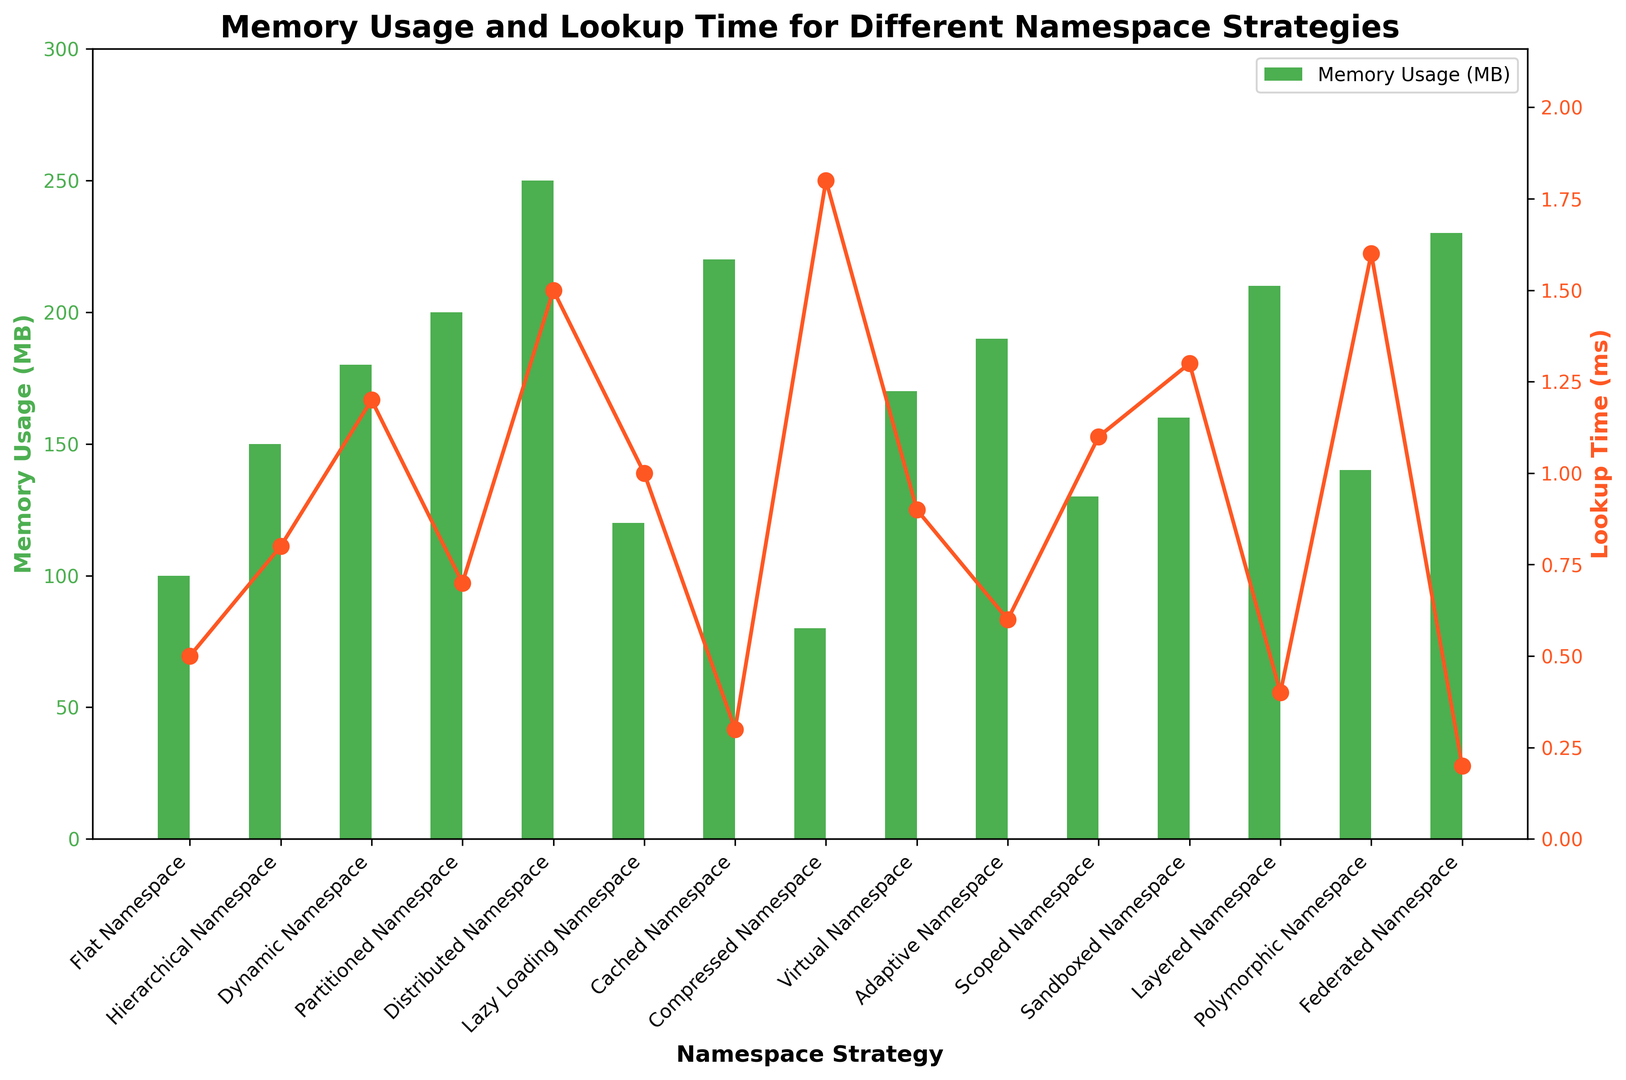Which namespace strategy has the highest memory usage? The green bar that represents memory usage is the tallest for the Distributed Namespace strategy.
Answer: Distributed Namespace Which namespace strategy has the lowest lookup time? The orange line representing lookup time has the lowest point for the Federated Namespace strategy.
Answer: Federated Namespace How much more memory does the Distributed Namespace use compared to the Compressed Namespace? The memory usage for the Distributed Namespace is 250 MB, and for the Compressed Namespace, it is 80 MB. The difference is 250 - 80 = 170 MB.
Answer: 170 MB Which namespace strategy has higher memory usage: Cached Namespace or Lazy Loading Namespace? Comparing the heights of the green bars, the Cached Namespace has a higher memory usage at 220 MB compared to 120 MB for the Lazy Loading Namespace.
Answer: Cached Namespace What is the combined lookup time for the Polymorphic Namespace and Layered Namespace? The lookup times for the Polymorphic Namespace and Layered Namespace are 1.6 ms and 0.4 ms respectively. Adding these, 1.6 + 0.4 = 2.0 ms.
Answer: 2.0 ms Which strategy has a lower memory usage: Scoped Namespace or Virtual Namespace? The green bar for Scoped Namespace is lower, indicating 130 MB, while the green bar for Virtual Namespace indicates 170 MB. Scoped Namespace uses less memory.
Answer: Scoped Namespace What is the average lookup time for all namespace strategies? Summing all the lookup times: 0.5 + 0.8 + 1.2 + 0.7 + 1.5 + 1.0 + 0.3 + 1.8 + 0.9 + 0.6 + 1.1 + 1.3 + 0.4 + 1.6 + 0.2 = 14.9 ms. There are 15 strategies total. The average is 14.9 / 15 ≈ 0.993 ms.
Answer: 0.993 ms Which namespace strategy shows a balance between lower memory usage and lookup time? The Lazy Loading Namespace strategy has a relatively low memory usage (120 MB) and a moderate lookup time (1.0 ms). It's not the lowest in either category but balances both.
Answer: Lazy Loading Namespace Is there any strategy whose lookup time exceeds 1.5 ms? Checking the orange line graph, there are two points above the 1.5 ms mark: Compressed Namespace (1.8 ms) and Distributed Namespace (1.5 ms).
Answer: Yes, Compressed Namespace What is the difference in lookup time between Flat Namespace and Adaptive Namespace? The lookup time for Flat Namespace is 0.5 ms, and for Adaptive Namespace, it is 0.6 ms. The difference is 0.6 - 0.5 = 0.1 ms.
Answer: 0.1 ms 